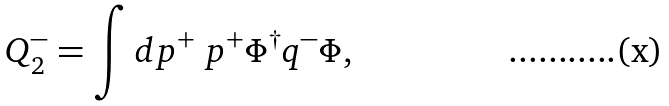Convert formula to latex. <formula><loc_0><loc_0><loc_500><loc_500>Q _ { 2 } ^ { - } = \int d p ^ { + } \ p ^ { + } \Phi ^ { \dagger } q ^ { - } \Phi ,</formula> 